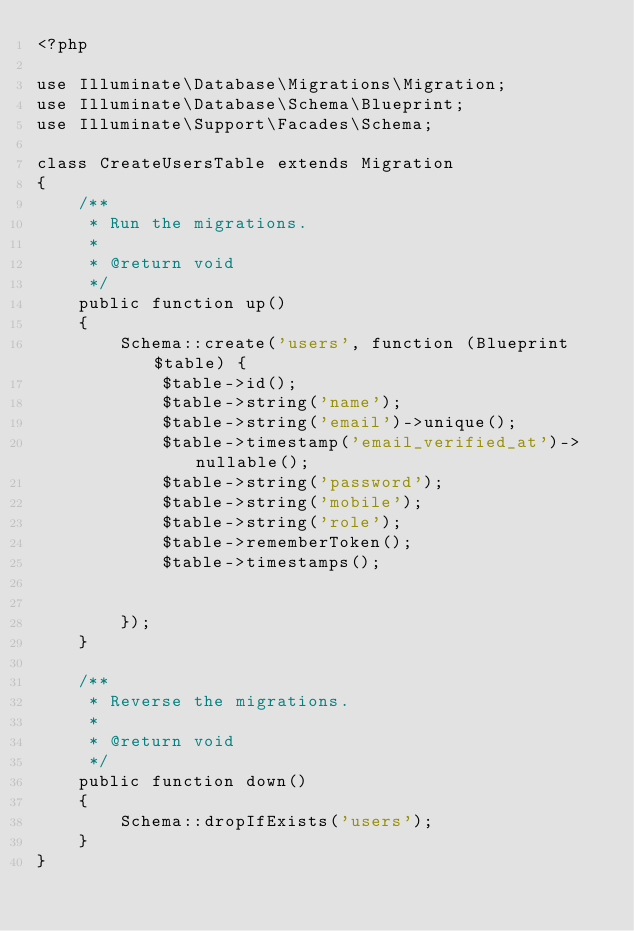Convert code to text. <code><loc_0><loc_0><loc_500><loc_500><_PHP_><?php

use Illuminate\Database\Migrations\Migration;
use Illuminate\Database\Schema\Blueprint;
use Illuminate\Support\Facades\Schema;

class CreateUsersTable extends Migration
{
    /**
     * Run the migrations.
     *
     * @return void
     */
    public function up()
    {
        Schema::create('users', function (Blueprint $table) {
            $table->id();
            $table->string('name');
            $table->string('email')->unique();
            $table->timestamp('email_verified_at')->nullable();
            $table->string('password');
            $table->string('mobile');
            $table->string('role');
            $table->rememberToken();
            $table->timestamps();
           
           
        });
    }

    /**
     * Reverse the migrations.
     *
     * @return void
     */
    public function down()
    {
        Schema::dropIfExists('users');
    }
}
</code> 